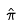<formula> <loc_0><loc_0><loc_500><loc_500>\hat { \pi }</formula> 